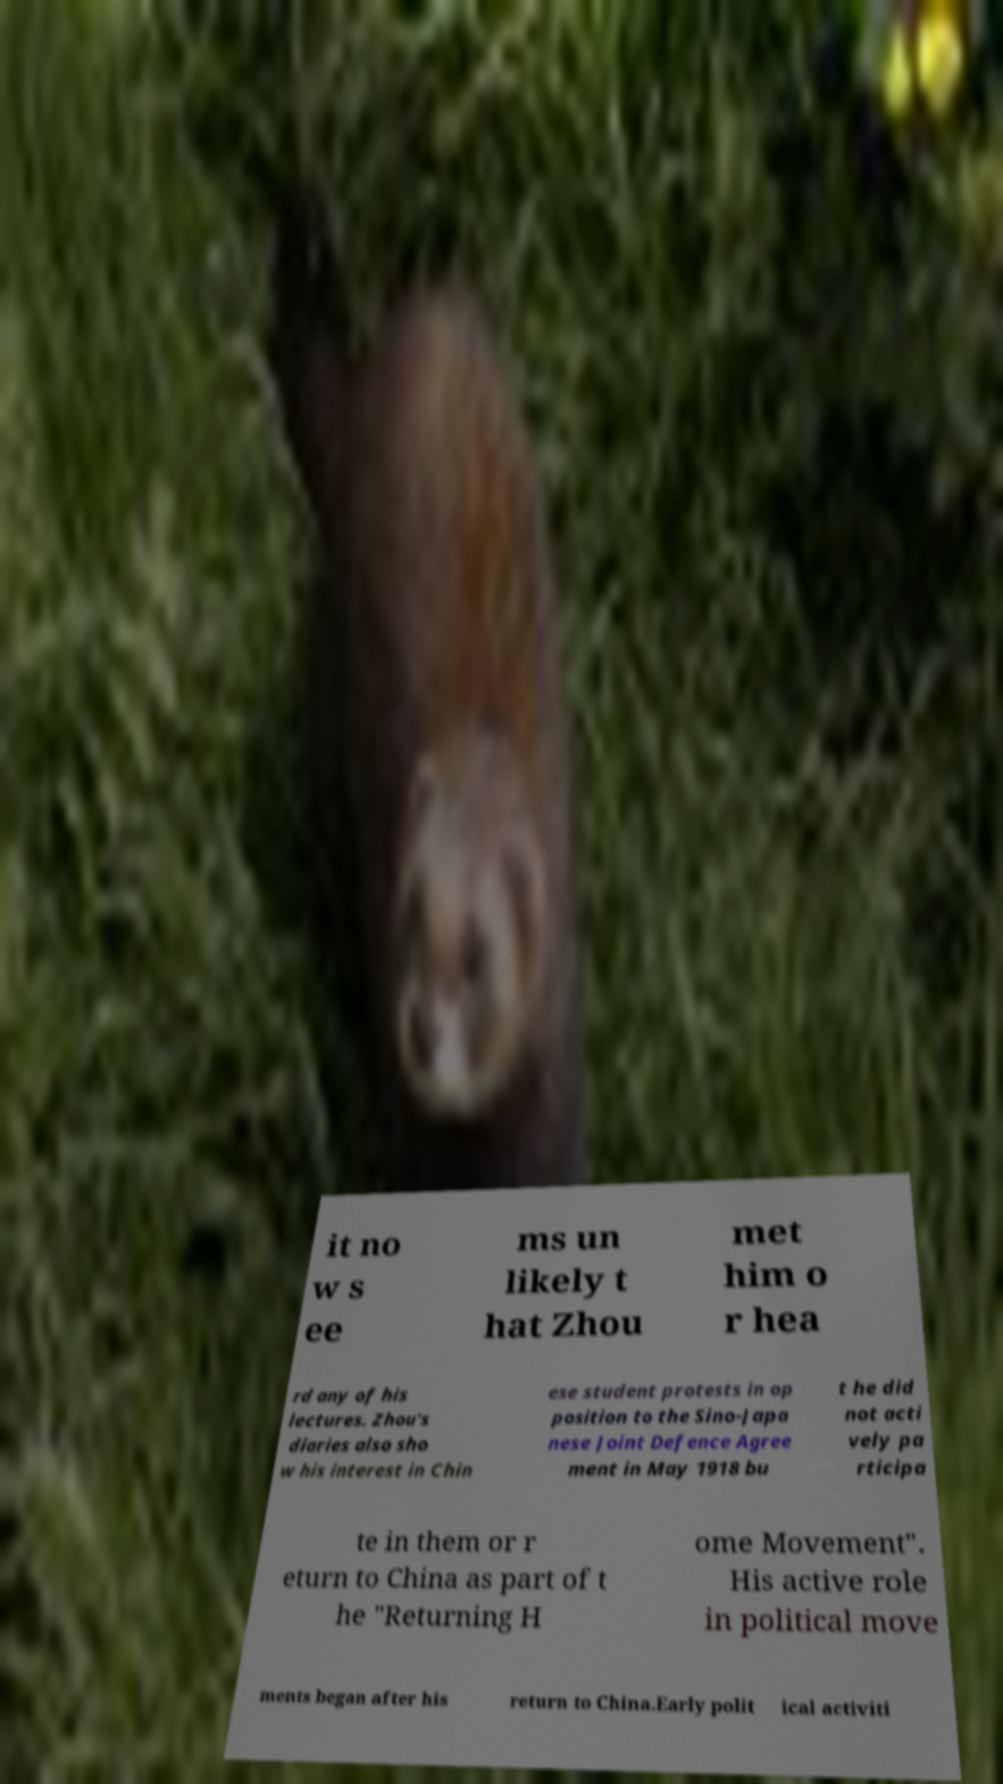Please identify and transcribe the text found in this image. it no w s ee ms un likely t hat Zhou met him o r hea rd any of his lectures. Zhou's diaries also sho w his interest in Chin ese student protests in op position to the Sino-Japa nese Joint Defence Agree ment in May 1918 bu t he did not acti vely pa rticipa te in them or r eturn to China as part of t he "Returning H ome Movement". His active role in political move ments began after his return to China.Early polit ical activiti 